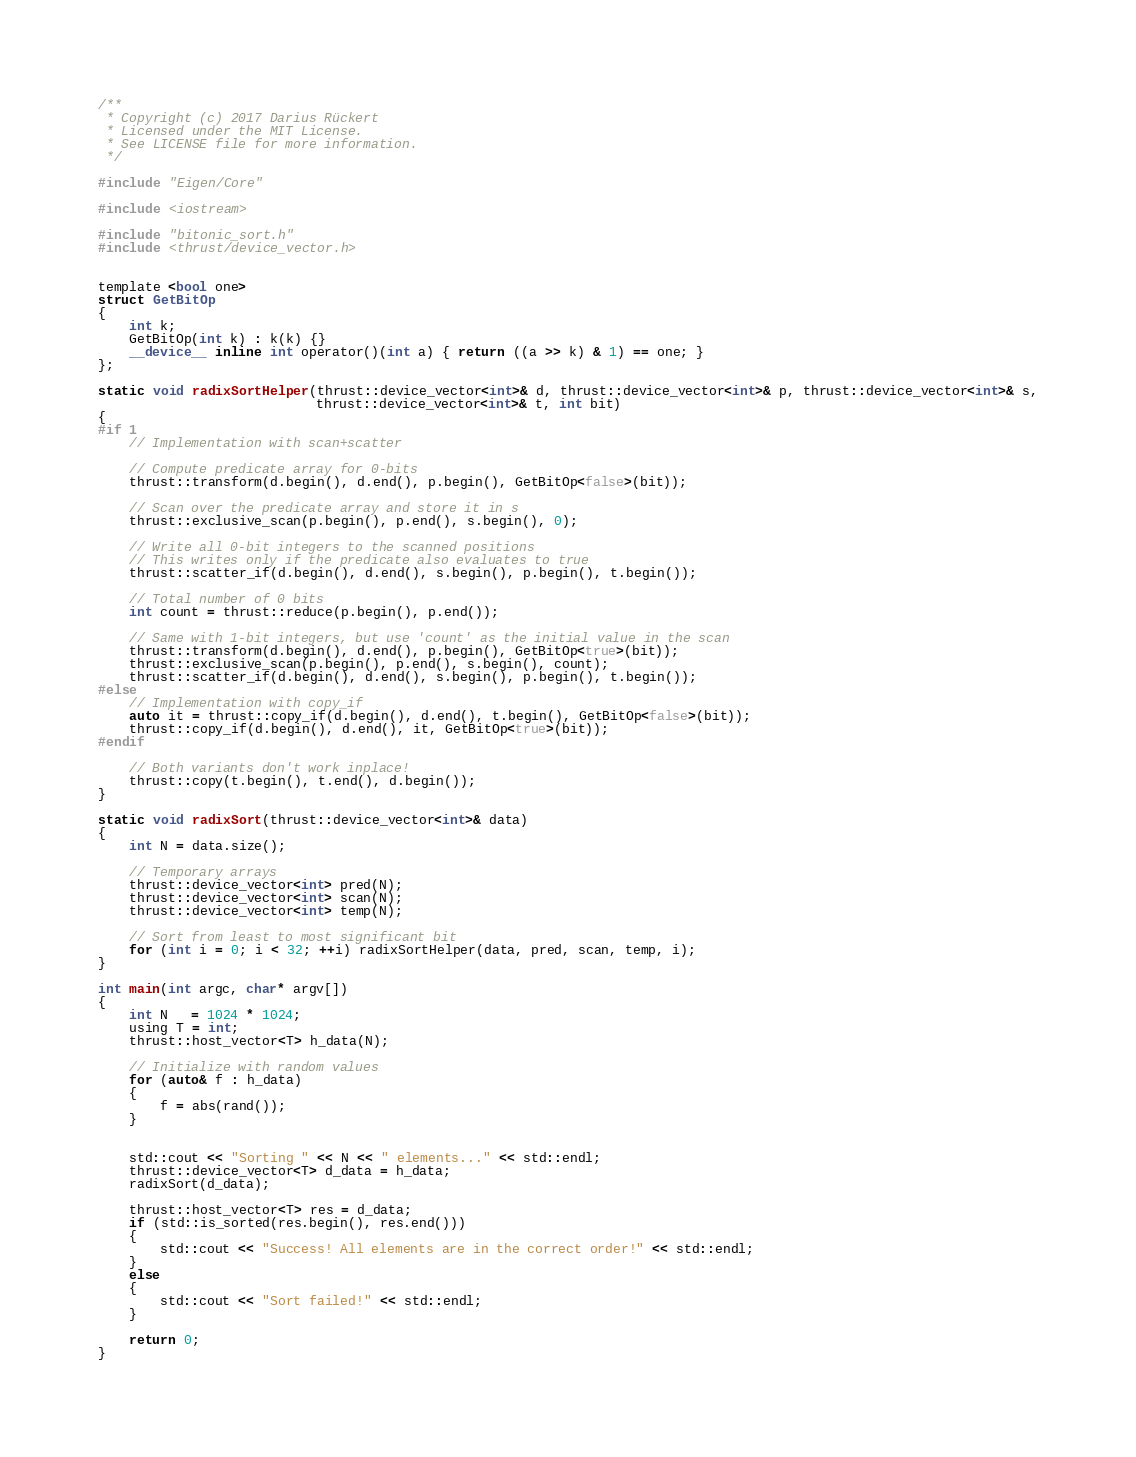<code> <loc_0><loc_0><loc_500><loc_500><_Cuda_>/**
 * Copyright (c) 2017 Darius Rückert
 * Licensed under the MIT License.
 * See LICENSE file for more information.
 */

#include "Eigen/Core"

#include <iostream>

#include "bitonic_sort.h"
#include <thrust/device_vector.h>


template <bool one>
struct GetBitOp
{
    int k;
    GetBitOp(int k) : k(k) {}
    __device__ inline int operator()(int a) { return ((a >> k) & 1) == one; }
};

static void radixSortHelper(thrust::device_vector<int>& d, thrust::device_vector<int>& p, thrust::device_vector<int>& s,
                            thrust::device_vector<int>& t, int bit)
{
#if 1
    // Implementation with scan+scatter

    // Compute predicate array for 0-bits
    thrust::transform(d.begin(), d.end(), p.begin(), GetBitOp<false>(bit));

    // Scan over the predicate array and store it in s
    thrust::exclusive_scan(p.begin(), p.end(), s.begin(), 0);

    // Write all 0-bit integers to the scanned positions
    // This writes only if the predicate also evaluates to true
    thrust::scatter_if(d.begin(), d.end(), s.begin(), p.begin(), t.begin());

    // Total number of 0 bits
    int count = thrust::reduce(p.begin(), p.end());

    // Same with 1-bit integers, but use 'count' as the initial value in the scan
    thrust::transform(d.begin(), d.end(), p.begin(), GetBitOp<true>(bit));
    thrust::exclusive_scan(p.begin(), p.end(), s.begin(), count);
    thrust::scatter_if(d.begin(), d.end(), s.begin(), p.begin(), t.begin());
#else
    // Implementation with copy_if
    auto it = thrust::copy_if(d.begin(), d.end(), t.begin(), GetBitOp<false>(bit));
    thrust::copy_if(d.begin(), d.end(), it, GetBitOp<true>(bit));
#endif

    // Both variants don't work inplace!
    thrust::copy(t.begin(), t.end(), d.begin());
}

static void radixSort(thrust::device_vector<int>& data)
{
    int N = data.size();

    // Temporary arrays
    thrust::device_vector<int> pred(N);
    thrust::device_vector<int> scan(N);
    thrust::device_vector<int> temp(N);

    // Sort from least to most significant bit
    for (int i = 0; i < 32; ++i) radixSortHelper(data, pred, scan, temp, i);
}

int main(int argc, char* argv[])
{
    int N   = 1024 * 1024;
    using T = int;
    thrust::host_vector<T> h_data(N);

    // Initialize with random values
    for (auto& f : h_data)
    {
        f = abs(rand());
    }


    std::cout << "Sorting " << N << " elements..." << std::endl;
    thrust::device_vector<T> d_data = h_data;
    radixSort(d_data);

    thrust::host_vector<T> res = d_data;
    if (std::is_sorted(res.begin(), res.end()))
    {
        std::cout << "Success! All elements are in the correct order!" << std::endl;
    }
    else
    {
        std::cout << "Sort failed!" << std::endl;
    }

    return 0;
}
</code> 